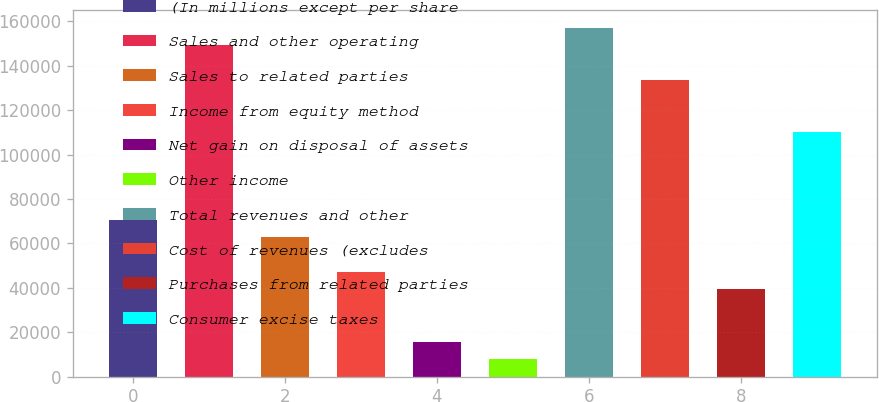Convert chart. <chart><loc_0><loc_0><loc_500><loc_500><bar_chart><fcel>(In millions except per share<fcel>Sales and other operating<fcel>Sales to related parties<fcel>Income from equity method<fcel>Net gain on disposal of assets<fcel>Other income<fcel>Total revenues and other<fcel>Cost of revenues (excludes<fcel>Purchases from related parties<fcel>Consumer excise taxes<nl><fcel>70717.1<fcel>149236<fcel>62865.2<fcel>47161.4<fcel>15753.8<fcel>7901.9<fcel>157088<fcel>133532<fcel>39309.5<fcel>109977<nl></chart> 